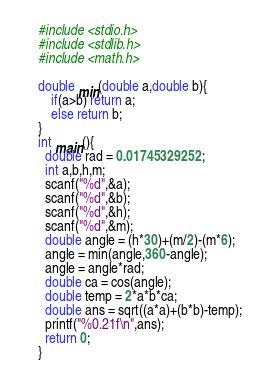<code> <loc_0><loc_0><loc_500><loc_500><_C_>    #include <stdio.h>
    #include <stdlib.h>
    #include <math.h>

    double min(double a,double b){
        if(a>b) return a;
        else return b;
    }
    int main(){
      double rad = 0.01745329252;
      int a,b,h,m;
      scanf("%d",&a);
      scanf("%d",&b);
      scanf("%d",&h);
      scanf("%d",&m);
      double angle = (h*30)+(m/2)-(m*6);
      angle = min(angle,360-angle);
      angle = angle*rad;
      double ca = cos(angle);
      double temp = 2*a*b*ca;
      double ans = sqrt((a*a)+(b*b)-temp);
      printf("%0.21f\n",ans);
      return 0;
    }
</code> 